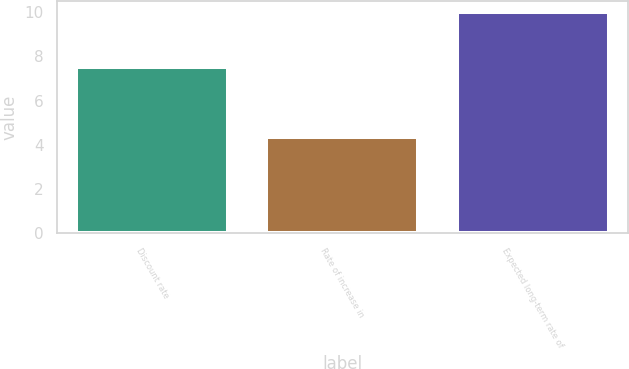Convert chart to OTSL. <chart><loc_0><loc_0><loc_500><loc_500><bar_chart><fcel>Discount rate<fcel>Rate of increase in<fcel>Expected long-term rate of<nl><fcel>7.5<fcel>4.33<fcel>10<nl></chart> 